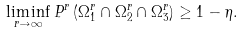Convert formula to latex. <formula><loc_0><loc_0><loc_500><loc_500>\liminf _ { r \to \infty } P ^ { r } \left ( \Omega ^ { r } _ { 1 } \cap \Omega ^ { r } _ { 2 } \cap \Omega ^ { r } _ { 3 } \right ) \geq 1 - \eta .</formula> 